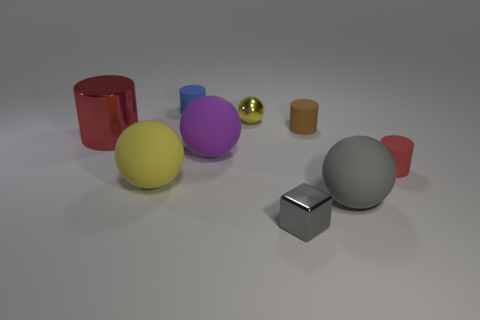Subtract 1 balls. How many balls are left? 3 Add 1 tiny gray shiny blocks. How many objects exist? 10 Subtract all balls. How many objects are left? 5 Subtract all red blocks. Subtract all metal objects. How many objects are left? 6 Add 3 red rubber things. How many red rubber things are left? 4 Add 5 large metal cylinders. How many large metal cylinders exist? 6 Subtract 1 purple balls. How many objects are left? 8 